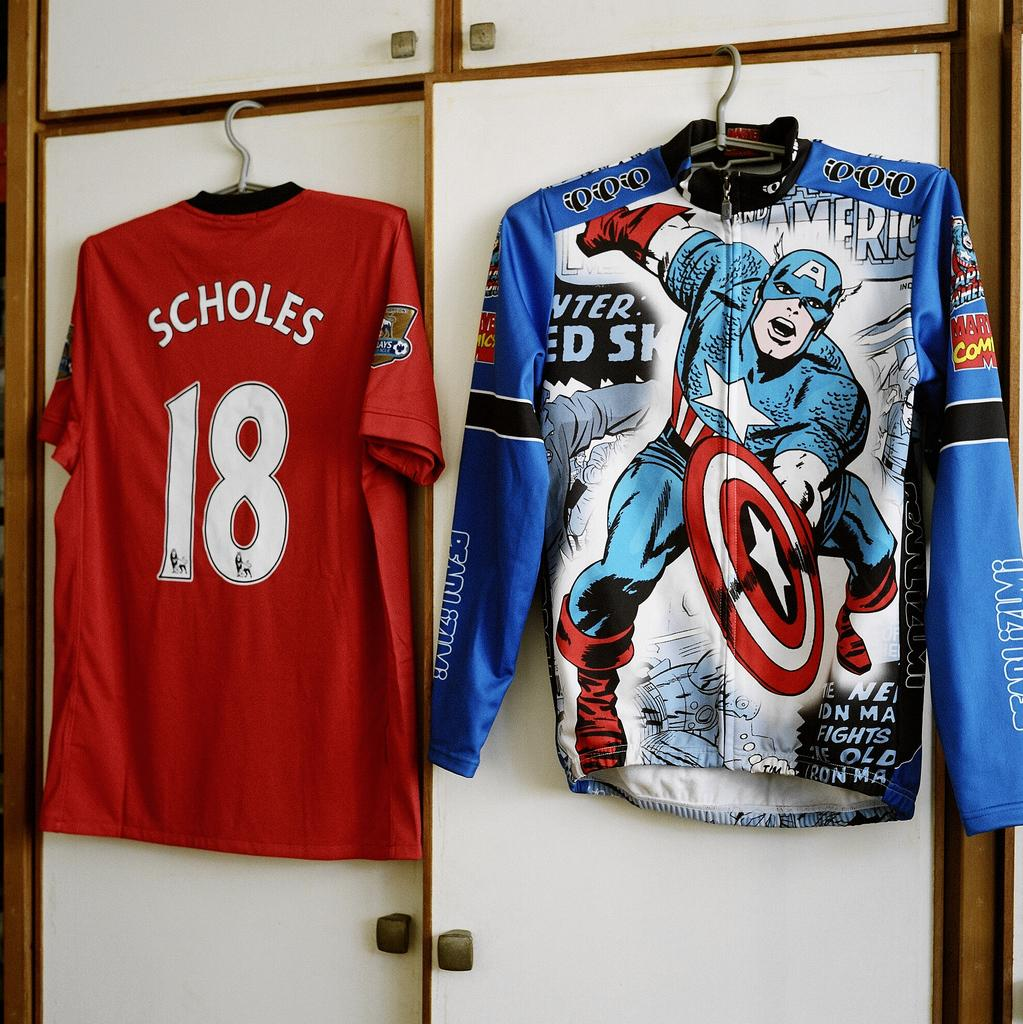<image>
Present a compact description of the photo's key features. A red shirt has the number 18 on it and hangs next to another shirt. 